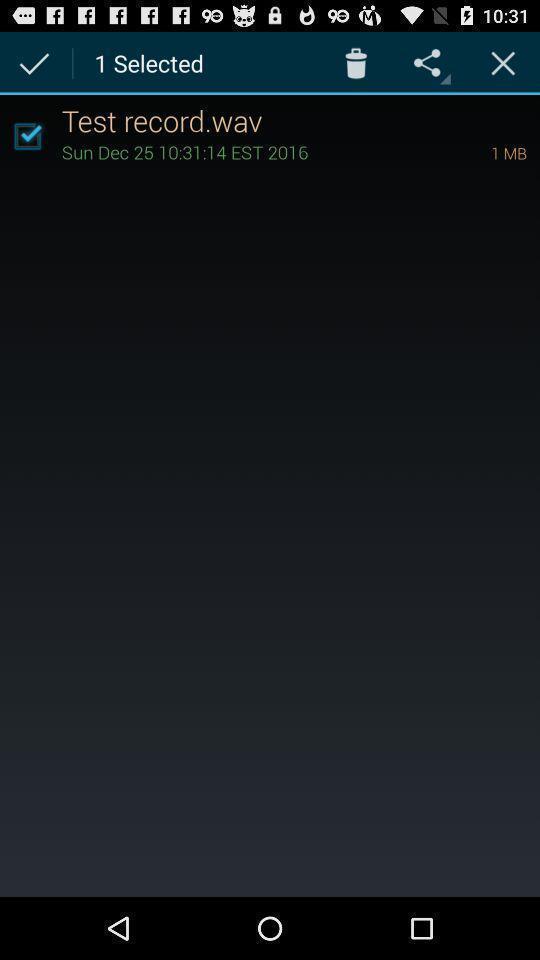Tell me what you see in this picture. Screen showing test record selected with options. 